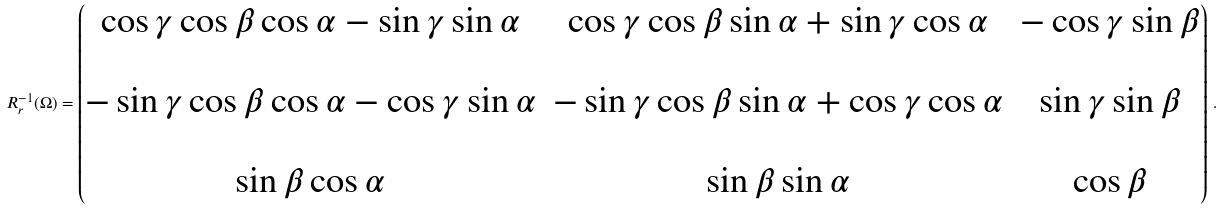<formula> <loc_0><loc_0><loc_500><loc_500>R _ { r } ^ { - 1 } ( \Omega ) = \begin{pmatrix} \cos \gamma \cos \beta \cos \alpha - \sin \gamma \sin \alpha & \cos \gamma \cos \beta \sin \alpha + \sin \gamma \cos \alpha & - \cos \gamma \sin \beta \\ \\ - \sin \gamma \cos \beta \cos \alpha - \cos \gamma \sin \alpha & - \sin \gamma \cos \beta \sin \alpha + \cos \gamma \cos \alpha & \sin \gamma \sin \beta \\ \\ \sin \beta \cos \alpha & \sin \beta \sin \alpha & \cos \beta \end{pmatrix} \, .</formula> 